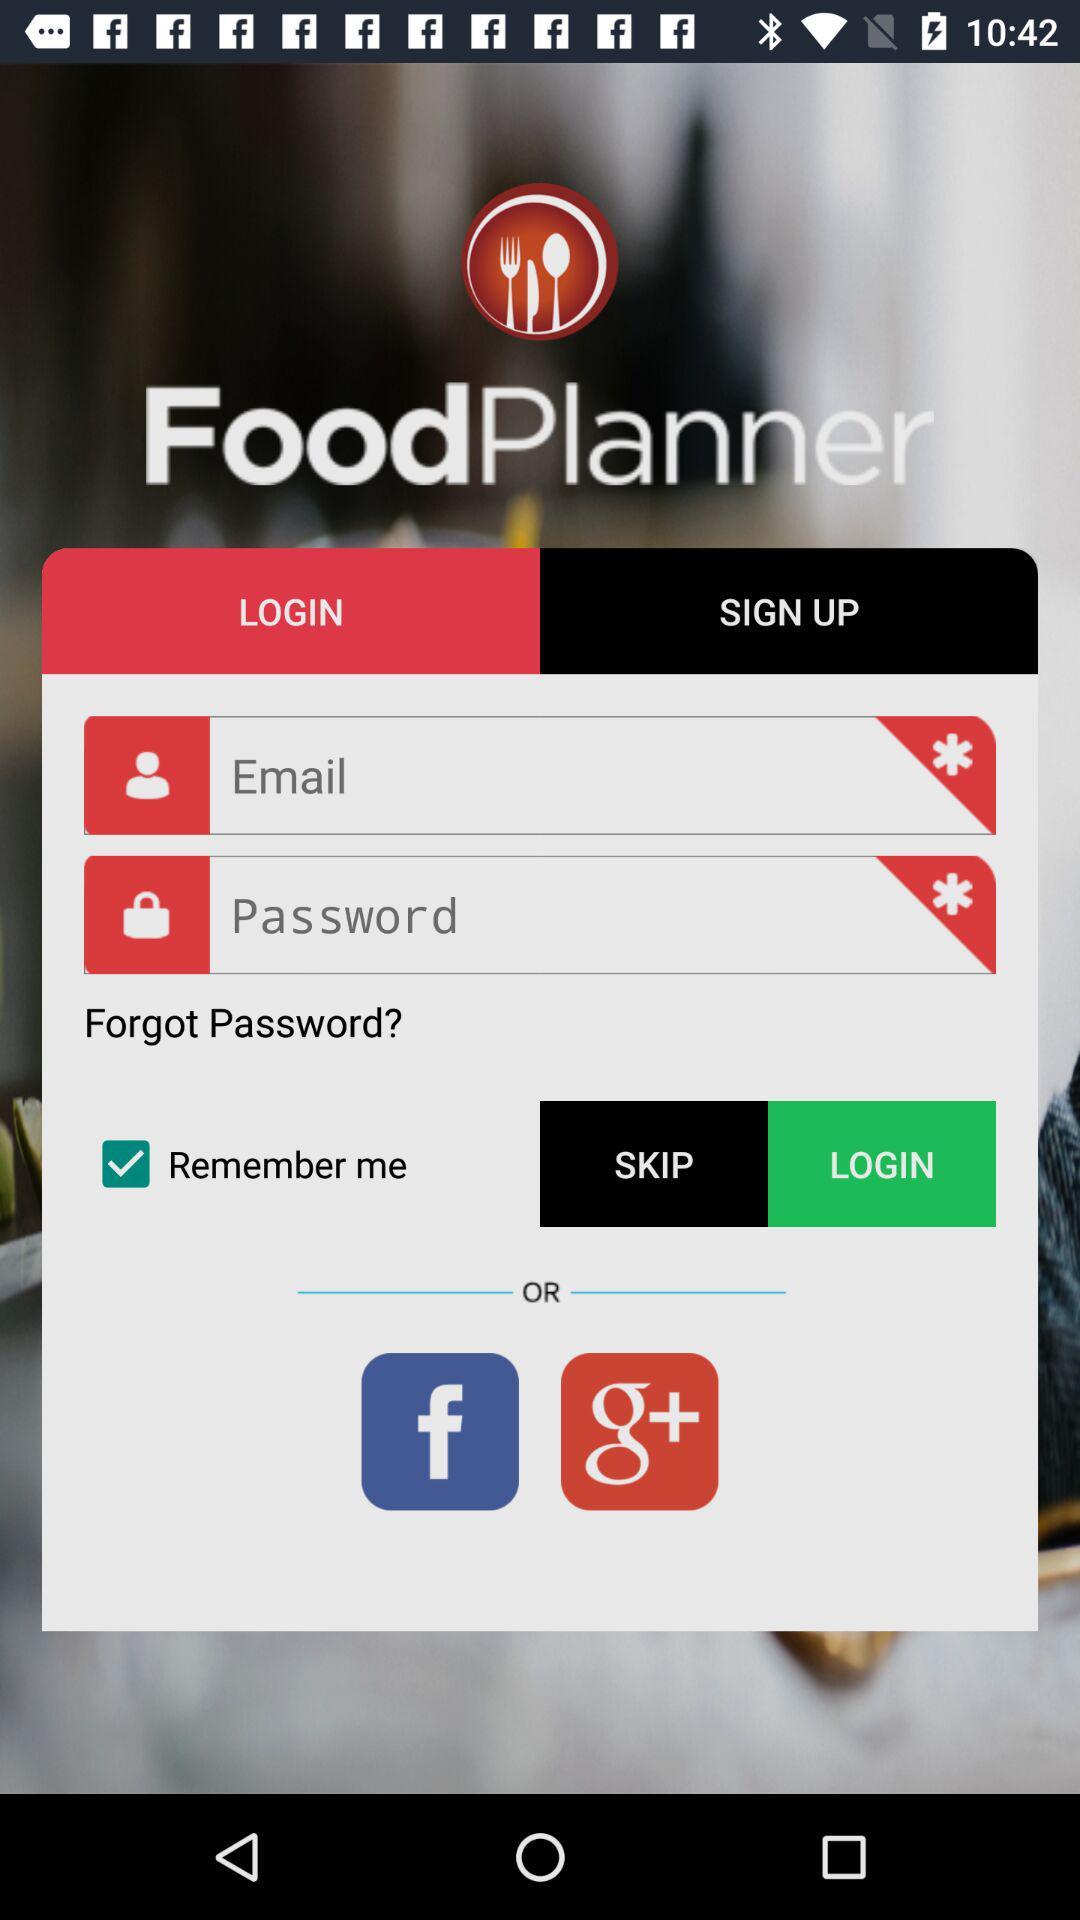What is the name of the application? The name of the application is "FoodPlanner". 